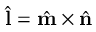Convert formula to latex. <formula><loc_0><loc_0><loc_500><loc_500>\hat { l } = \hat { m } \times \hat { n }</formula> 